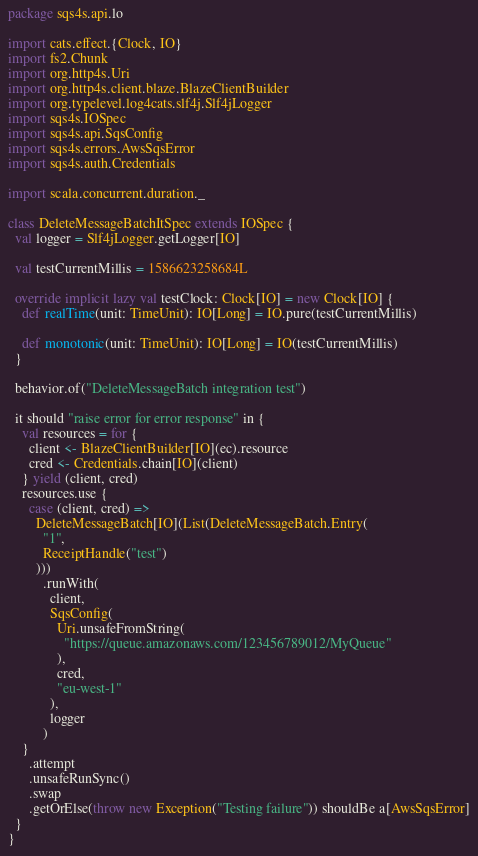Convert code to text. <code><loc_0><loc_0><loc_500><loc_500><_Scala_>package sqs4s.api.lo

import cats.effect.{Clock, IO}
import fs2.Chunk
import org.http4s.Uri
import org.http4s.client.blaze.BlazeClientBuilder
import org.typelevel.log4cats.slf4j.Slf4jLogger
import sqs4s.IOSpec
import sqs4s.api.SqsConfig
import sqs4s.errors.AwsSqsError
import sqs4s.auth.Credentials

import scala.concurrent.duration._

class DeleteMessageBatchItSpec extends IOSpec {
  val logger = Slf4jLogger.getLogger[IO]

  val testCurrentMillis = 1586623258684L

  override implicit lazy val testClock: Clock[IO] = new Clock[IO] {
    def realTime(unit: TimeUnit): IO[Long] = IO.pure(testCurrentMillis)

    def monotonic(unit: TimeUnit): IO[Long] = IO(testCurrentMillis)
  }

  behavior.of("DeleteMessageBatch integration test")

  it should "raise error for error response" in {
    val resources = for {
      client <- BlazeClientBuilder[IO](ec).resource
      cred <- Credentials.chain[IO](client)
    } yield (client, cred)
    resources.use {
      case (client, cred) =>
        DeleteMessageBatch[IO](List(DeleteMessageBatch.Entry(
          "1",
          ReceiptHandle("test")
        )))
          .runWith(
            client,
            SqsConfig(
              Uri.unsafeFromString(
                "https://queue.amazonaws.com/123456789012/MyQueue"
              ),
              cred,
              "eu-west-1"
            ),
            logger
          )
    }
      .attempt
      .unsafeRunSync()
      .swap
      .getOrElse(throw new Exception("Testing failure")) shouldBe a[AwsSqsError]
  }
}
</code> 